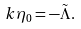Convert formula to latex. <formula><loc_0><loc_0><loc_500><loc_500>k \eta _ { 0 } = - \tilde { \Lambda } .</formula> 